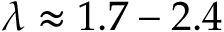Convert formula to latex. <formula><loc_0><loc_0><loc_500><loc_500>\lambda \approx 1 . 7 - 2 . 4</formula> 